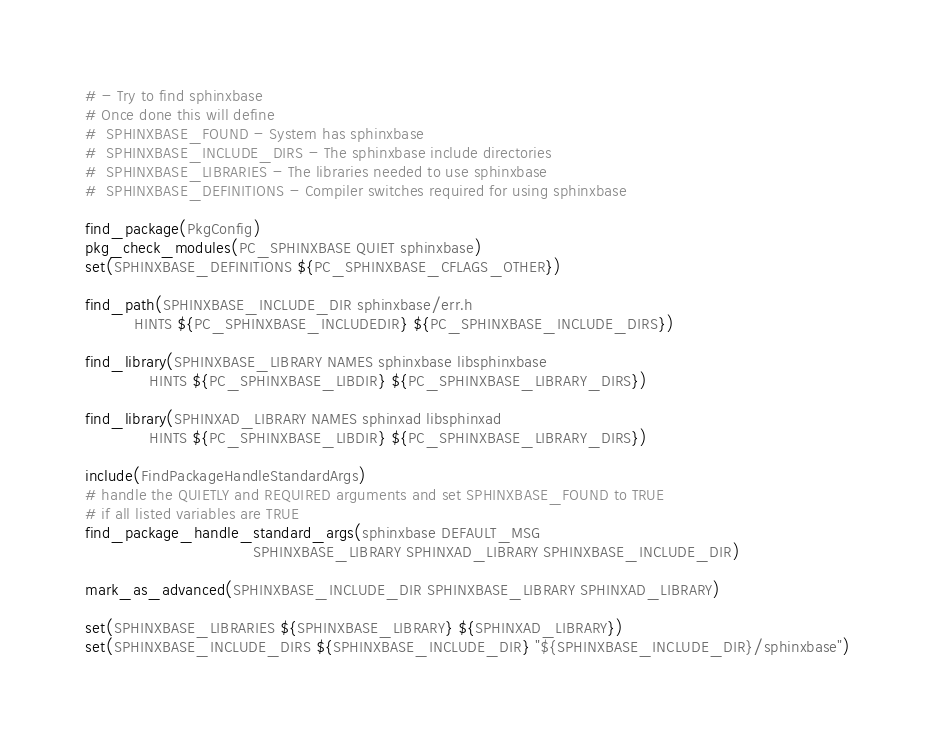<code> <loc_0><loc_0><loc_500><loc_500><_CMake_># - Try to find sphinxbase
# Once done this will define
#  SPHINXBASE_FOUND - System has sphinxbase
#  SPHINXBASE_INCLUDE_DIRS - The sphinxbase include directories
#  SPHINXBASE_LIBRARIES - The libraries needed to use sphinxbase
#  SPHINXBASE_DEFINITIONS - Compiler switches required for using sphinxbase

find_package(PkgConfig)
pkg_check_modules(PC_SPHINXBASE QUIET sphinxbase)
set(SPHINXBASE_DEFINITIONS ${PC_SPHINXBASE_CFLAGS_OTHER})

find_path(SPHINXBASE_INCLUDE_DIR sphinxbase/err.h
          HINTS ${PC_SPHINXBASE_INCLUDEDIR} ${PC_SPHINXBASE_INCLUDE_DIRS})

find_library(SPHINXBASE_LIBRARY NAMES sphinxbase libsphinxbase
             HINTS ${PC_SPHINXBASE_LIBDIR} ${PC_SPHINXBASE_LIBRARY_DIRS})

find_library(SPHINXAD_LIBRARY NAMES sphinxad libsphinxad
             HINTS ${PC_SPHINXBASE_LIBDIR} ${PC_SPHINXBASE_LIBRARY_DIRS})

include(FindPackageHandleStandardArgs)
# handle the QUIETLY and REQUIRED arguments and set SPHINXBASE_FOUND to TRUE
# if all listed variables are TRUE
find_package_handle_standard_args(sphinxbase DEFAULT_MSG
                                  SPHINXBASE_LIBRARY SPHINXAD_LIBRARY SPHINXBASE_INCLUDE_DIR)

mark_as_advanced(SPHINXBASE_INCLUDE_DIR SPHINXBASE_LIBRARY SPHINXAD_LIBRARY)

set(SPHINXBASE_LIBRARIES ${SPHINXBASE_LIBRARY} ${SPHINXAD_LIBRARY})
set(SPHINXBASE_INCLUDE_DIRS ${SPHINXBASE_INCLUDE_DIR} "${SPHINXBASE_INCLUDE_DIR}/sphinxbase")
</code> 